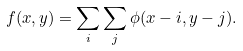<formula> <loc_0><loc_0><loc_500><loc_500>f ( x , y ) = \sum _ { i } \sum _ { j } \phi ( x - i , y - j ) .</formula> 